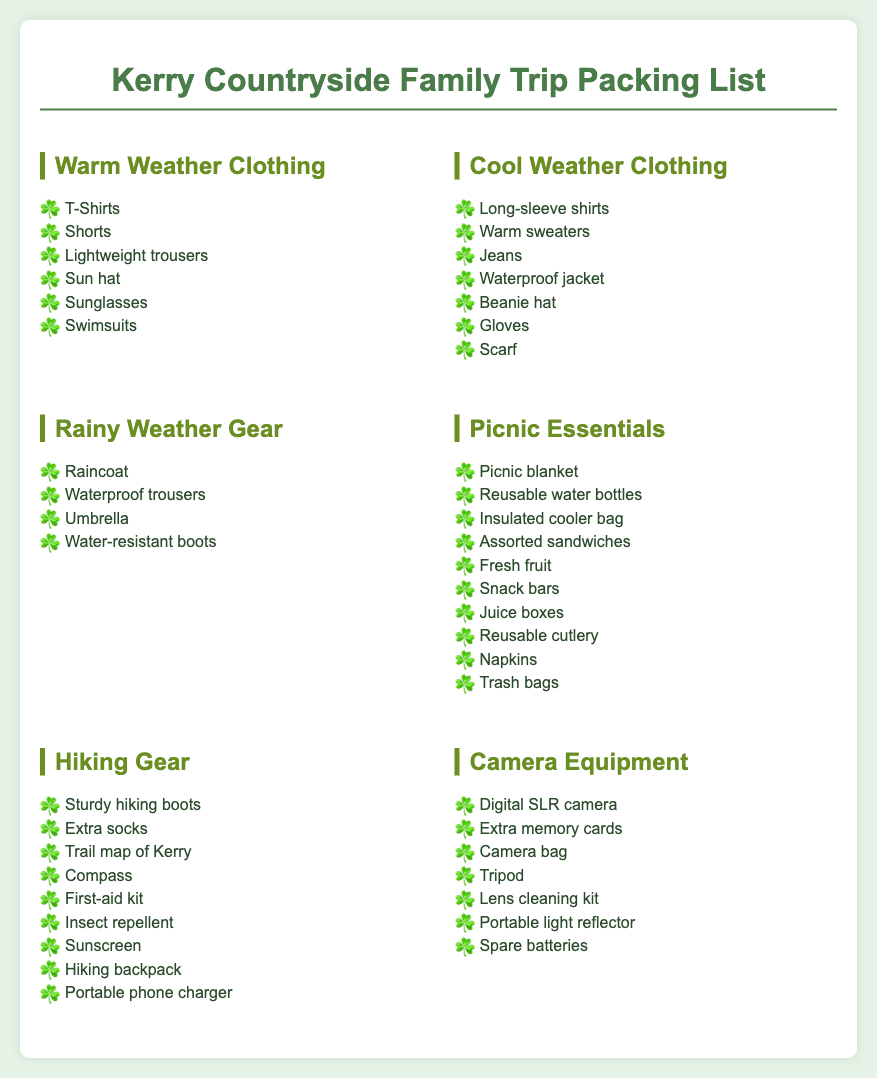what should you pack for warm weather? The list includes items specifically for warm weather conditions such as T-Shirts, Shorts, and Swimsuits.
Answer: T-Shirts, Shorts, Lightweight trousers, Sun hat, Sunglasses, Swimsuits how many items are in the rainy weather gear section? The rainy weather gear section contains four items listed for protection against rain.
Answer: 4 what is included in the picnic essentials? The picnic essentials list includes items needed for a picnic, such as a blanket and reusable bottles.
Answer: Picnic blanket, Reusable water bottles, Insulated cooler bag, Assorted sandwiches, Fresh fruit, Snack bars, Juice boxes, Reusable cutlery, Napkins, Trash bags which clothing item is suggested for cool weather? The cool weather clothing section includes items designed to keep warm, like a Waterproof jacket.
Answer: Waterproof jacket what is the main purpose of the hiking gear listed? The hiking gear is intended for safe and comfortable hiking experiences in the countryside.
Answer: Safety and comfort in hiking how many camera equipment items are listed? Counting the items under camera equipment reveals the total amount provided for photography gear.
Answer: 6 what type of hat is recommended for warm weather? The warm weather clothing section suggests a specific type of headwear for sunny conditions.
Answer: Sun hat what is essential to pack for a family picnic? Essential items are found in the picnic section that facilitate an enjoyable outing with family.
Answer: Picnic blanket, Assorted sandwiches, Fresh fruit, Water bottles which footwear is highlighted for hiking? The hiking gear section emphasizes a particular type of footwear necessary for hiking trails.
Answer: Sturdy hiking boots 